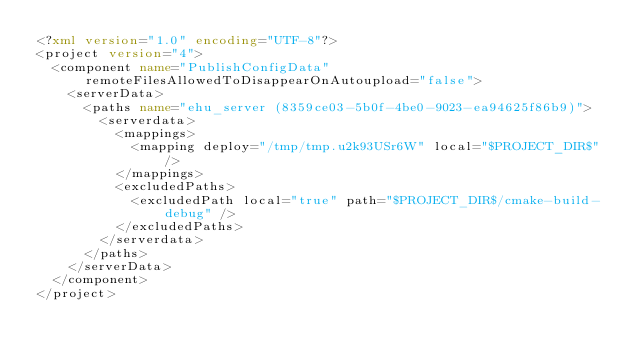<code> <loc_0><loc_0><loc_500><loc_500><_XML_><?xml version="1.0" encoding="UTF-8"?>
<project version="4">
  <component name="PublishConfigData" remoteFilesAllowedToDisappearOnAutoupload="false">
    <serverData>
      <paths name="ehu_server (8359ce03-5b0f-4be0-9023-ea94625f86b9)">
        <serverdata>
          <mappings>
            <mapping deploy="/tmp/tmp.u2k93USr6W" local="$PROJECT_DIR$" />
          </mappings>
          <excludedPaths>
            <excludedPath local="true" path="$PROJECT_DIR$/cmake-build-debug" />
          </excludedPaths>
        </serverdata>
      </paths>
    </serverData>
  </component>
</project></code> 